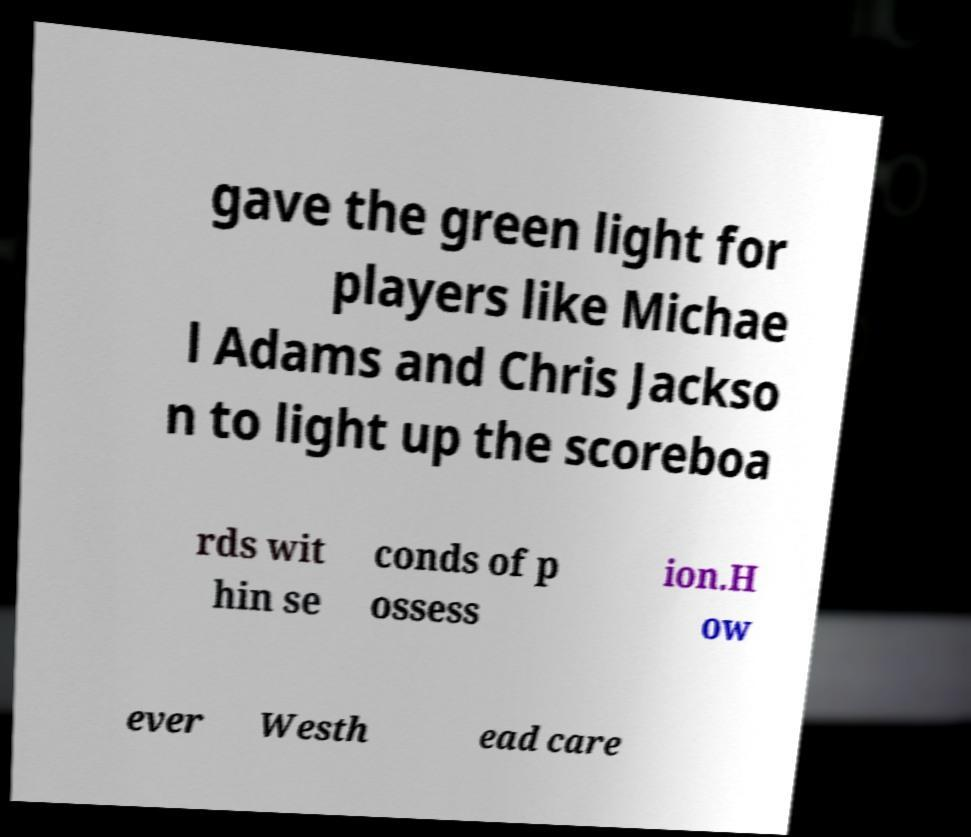Could you assist in decoding the text presented in this image and type it out clearly? gave the green light for players like Michae l Adams and Chris Jackso n to light up the scoreboa rds wit hin se conds of p ossess ion.H ow ever Westh ead care 